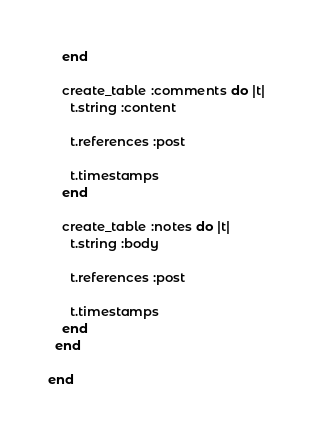Convert code to text. <code><loc_0><loc_0><loc_500><loc_500><_Ruby_>    end

    create_table :comments do |t|
      t.string :content

      t.references :post

      t.timestamps
    end

    create_table :notes do |t|
      t.string :body

      t.references :post

      t.timestamps
    end
  end

end
</code> 